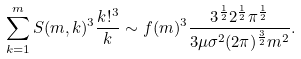Convert formula to latex. <formula><loc_0><loc_0><loc_500><loc_500>\sum _ { k = 1 } ^ { m } S ( m , k ) ^ { 3 } \frac { k ! ^ { 3 } } { k } \sim f ( m ) ^ { 3 } \frac { 3 ^ { \frac { 1 } { 2 } } 2 ^ { \frac { 1 } { 2 } } \pi ^ { \frac { 1 } { 2 } } } { 3 \mu \sigma ^ { 2 } ( 2 \pi ) ^ { \frac { 3 } { 2 } } m ^ { 2 } } .</formula> 